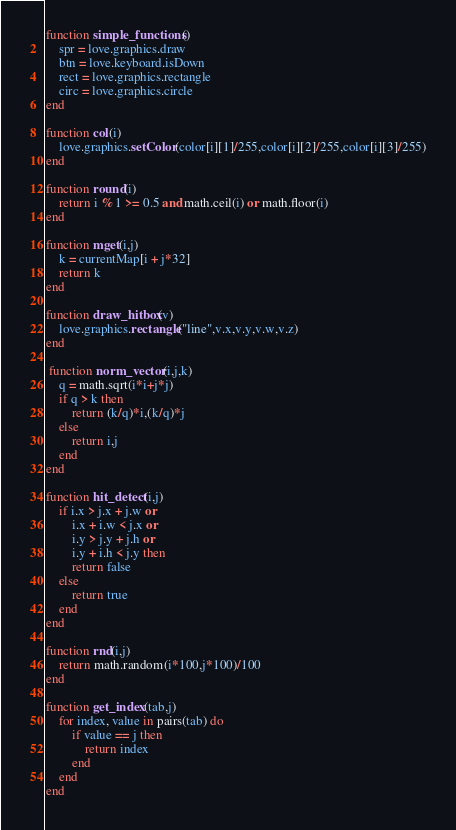<code> <loc_0><loc_0><loc_500><loc_500><_Lua_>
function simple_functions()
	spr = love.graphics.draw
	btn = love.keyboard.isDown
	rect = love.graphics.rectangle
	circ = love.graphics.circle
end

function col(i)
	love.graphics.setColor(color[i][1]/255,color[i][2]/255,color[i][3]/255)
end

function round(i)
	return i % 1 >= 0.5 and math.ceil(i) or math.floor(i)
end

function mget(i,j)
	k = currentMap[i + j*32]
	return k
end

function draw_hitbox(v)
	love.graphics.rectangle("line",v.x,v.y,v.w,v.z)
end

 function norm_vector(i,j,k)
    q = math.sqrt(i*i+j*j)
    if q > k then
        return (k/q)*i,(k/q)*j
    else
        return i,j
    end
end

function hit_detect(i,j)
	if i.x > j.x + j.w or
		i.x + i.w < j.x or
		i.y > j.y + j.h or
		i.y + i.h < j.y then
		return false
	else
		return true
	end
end

function rnd(i,j)
	return math.random(i*100,j*100)/100
end

function get_index(tab,j)
	for index, value in pairs(tab) do
		if value == j then
			return index
		end
	end
end</code> 